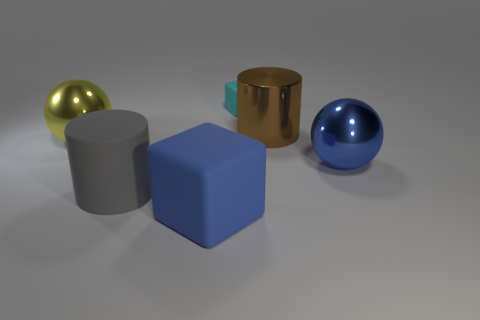In what kind of setting might we find these objects together? These objects could feasibly be found together in a modern and minimalist interior design setting, such as an art studio, a contemporary home decor showroom, or within a scene of a futuristic movie where they serve a decorative purpose, highlighting a taste for abstract and geometric aesthetics. 